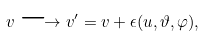<formula> <loc_0><loc_0><loc_500><loc_500>v \longrightarrow v ^ { \prime } = v + \epsilon ( u , \vartheta , \varphi ) ,</formula> 